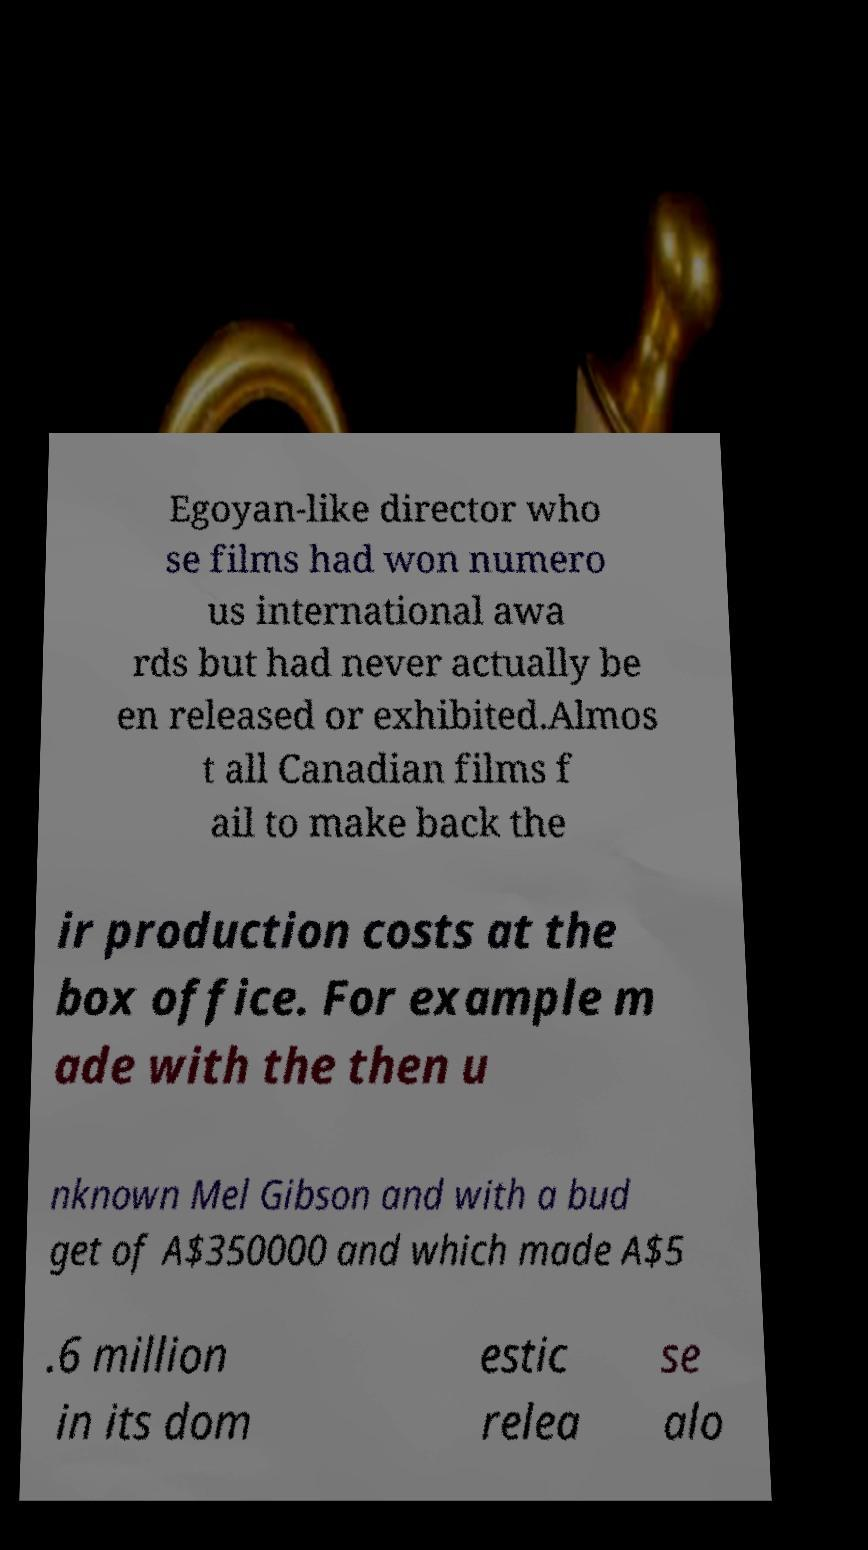There's text embedded in this image that I need extracted. Can you transcribe it verbatim? Egoyan-like director who se films had won numero us international awa rds but had never actually be en released or exhibited.Almos t all Canadian films f ail to make back the ir production costs at the box office. For example m ade with the then u nknown Mel Gibson and with a bud get of A$350000 and which made A$5 .6 million in its dom estic relea se alo 